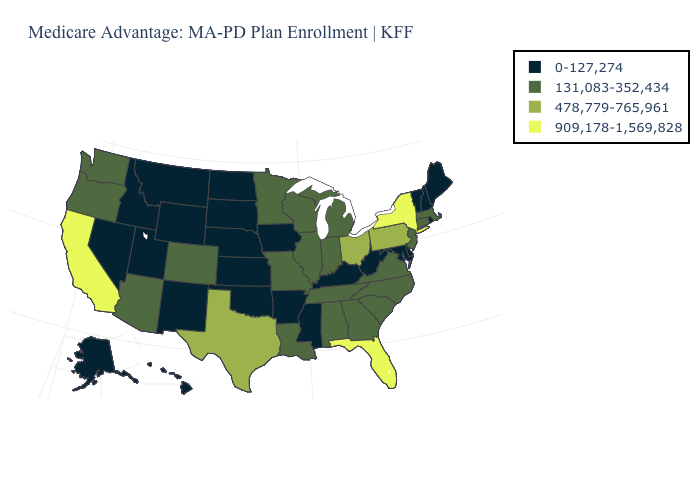What is the value of Vermont?
Quick response, please. 0-127,274. Does the map have missing data?
Keep it brief. No. How many symbols are there in the legend?
Give a very brief answer. 4. Among the states that border Louisiana , does Texas have the highest value?
Short answer required. Yes. Which states have the lowest value in the USA?
Be succinct. Alaska, Arkansas, Delaware, Hawaii, Iowa, Idaho, Kansas, Kentucky, Maryland, Maine, Mississippi, Montana, North Dakota, Nebraska, New Hampshire, New Mexico, Nevada, Oklahoma, Rhode Island, South Dakota, Utah, Vermont, West Virginia, Wyoming. How many symbols are there in the legend?
Short answer required. 4. What is the value of West Virginia?
Keep it brief. 0-127,274. Does Virginia have the same value as Alabama?
Quick response, please. Yes. Name the states that have a value in the range 478,779-765,961?
Keep it brief. Ohio, Pennsylvania, Texas. Which states hav the highest value in the South?
Short answer required. Florida. Which states have the lowest value in the USA?
Give a very brief answer. Alaska, Arkansas, Delaware, Hawaii, Iowa, Idaho, Kansas, Kentucky, Maryland, Maine, Mississippi, Montana, North Dakota, Nebraska, New Hampshire, New Mexico, Nevada, Oklahoma, Rhode Island, South Dakota, Utah, Vermont, West Virginia, Wyoming. What is the value of Oregon?
Answer briefly. 131,083-352,434. Does the map have missing data?
Give a very brief answer. No. Among the states that border Alabama , which have the highest value?
Keep it brief. Florida. Among the states that border Illinois , which have the lowest value?
Write a very short answer. Iowa, Kentucky. 